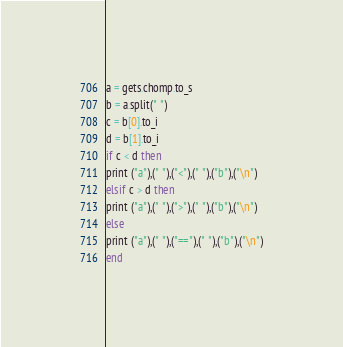<code> <loc_0><loc_0><loc_500><loc_500><_Ruby_>a = gets.chomp.to_s
b = a.split(" ")
c = b[0].to_i
d = b[1].to_i
if c < d then
print ("a"),(" "),("<"),(" "),("b"),("\n")
elsif c > d then
print ("a"),(" "),(">"),(" "),("b"),("\n")
else 
print ("a"),(" "),("=="),(" "),("b"),("\n")
end</code> 